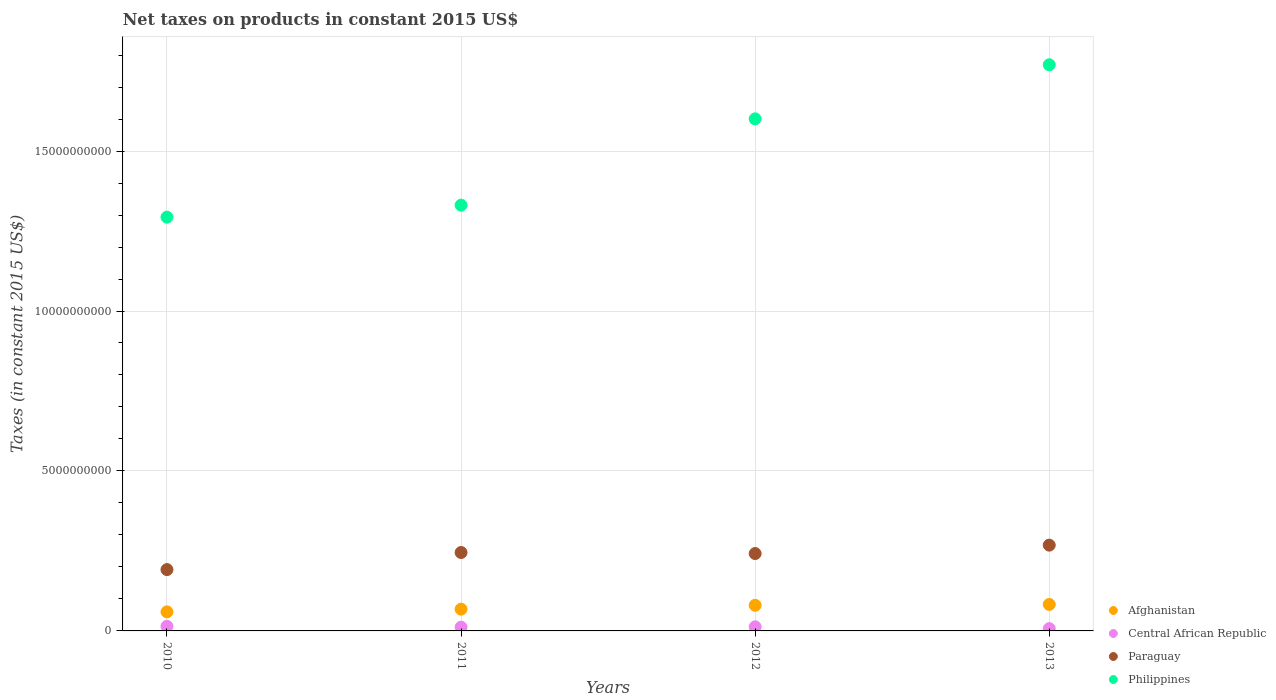How many different coloured dotlines are there?
Keep it short and to the point. 4. Is the number of dotlines equal to the number of legend labels?
Your answer should be compact. Yes. What is the net taxes on products in Paraguay in 2010?
Your answer should be compact. 1.92e+09. Across all years, what is the maximum net taxes on products in Philippines?
Provide a succinct answer. 1.77e+1. Across all years, what is the minimum net taxes on products in Paraguay?
Offer a terse response. 1.92e+09. In which year was the net taxes on products in Afghanistan minimum?
Ensure brevity in your answer.  2010. What is the total net taxes on products in Central African Republic in the graph?
Provide a short and direct response. 4.61e+08. What is the difference between the net taxes on products in Paraguay in 2012 and that in 2013?
Give a very brief answer. -2.63e+08. What is the difference between the net taxes on products in Philippines in 2013 and the net taxes on products in Paraguay in 2010?
Ensure brevity in your answer.  1.58e+1. What is the average net taxes on products in Paraguay per year?
Keep it short and to the point. 2.37e+09. In the year 2012, what is the difference between the net taxes on products in Philippines and net taxes on products in Afghanistan?
Provide a succinct answer. 1.52e+1. What is the ratio of the net taxes on products in Afghanistan in 2010 to that in 2013?
Make the answer very short. 0.72. What is the difference between the highest and the second highest net taxes on products in Paraguay?
Provide a short and direct response. 2.30e+08. What is the difference between the highest and the lowest net taxes on products in Paraguay?
Offer a terse response. 7.64e+08. In how many years, is the net taxes on products in Paraguay greater than the average net taxes on products in Paraguay taken over all years?
Your answer should be very brief. 3. Is it the case that in every year, the sum of the net taxes on products in Philippines and net taxes on products in Afghanistan  is greater than the net taxes on products in Central African Republic?
Provide a short and direct response. Yes. Is the net taxes on products in Central African Republic strictly less than the net taxes on products in Philippines over the years?
Give a very brief answer. Yes. How many dotlines are there?
Provide a short and direct response. 4. What is the difference between two consecutive major ticks on the Y-axis?
Your answer should be compact. 5.00e+09. Does the graph contain any zero values?
Give a very brief answer. No. Does the graph contain grids?
Your response must be concise. Yes. How many legend labels are there?
Your answer should be very brief. 4. How are the legend labels stacked?
Your answer should be very brief. Vertical. What is the title of the graph?
Your answer should be compact. Net taxes on products in constant 2015 US$. What is the label or title of the X-axis?
Your answer should be compact. Years. What is the label or title of the Y-axis?
Your answer should be compact. Taxes (in constant 2015 US$). What is the Taxes (in constant 2015 US$) in Afghanistan in 2010?
Your response must be concise. 5.96e+08. What is the Taxes (in constant 2015 US$) of Central African Republic in 2010?
Keep it short and to the point. 1.43e+08. What is the Taxes (in constant 2015 US$) of Paraguay in 2010?
Keep it short and to the point. 1.92e+09. What is the Taxes (in constant 2015 US$) in Philippines in 2010?
Offer a very short reply. 1.29e+1. What is the Taxes (in constant 2015 US$) of Afghanistan in 2011?
Provide a succinct answer. 6.80e+08. What is the Taxes (in constant 2015 US$) in Central African Republic in 2011?
Provide a short and direct response. 1.17e+08. What is the Taxes (in constant 2015 US$) in Paraguay in 2011?
Provide a succinct answer. 2.45e+09. What is the Taxes (in constant 2015 US$) in Philippines in 2011?
Make the answer very short. 1.33e+1. What is the Taxes (in constant 2015 US$) of Afghanistan in 2012?
Offer a very short reply. 8.01e+08. What is the Taxes (in constant 2015 US$) of Central African Republic in 2012?
Keep it short and to the point. 1.28e+08. What is the Taxes (in constant 2015 US$) in Paraguay in 2012?
Give a very brief answer. 2.42e+09. What is the Taxes (in constant 2015 US$) of Philippines in 2012?
Make the answer very short. 1.60e+1. What is the Taxes (in constant 2015 US$) of Afghanistan in 2013?
Offer a very short reply. 8.28e+08. What is the Taxes (in constant 2015 US$) of Central African Republic in 2013?
Your answer should be very brief. 7.17e+07. What is the Taxes (in constant 2015 US$) in Paraguay in 2013?
Offer a terse response. 2.68e+09. What is the Taxes (in constant 2015 US$) of Philippines in 2013?
Give a very brief answer. 1.77e+1. Across all years, what is the maximum Taxes (in constant 2015 US$) of Afghanistan?
Provide a succinct answer. 8.28e+08. Across all years, what is the maximum Taxes (in constant 2015 US$) of Central African Republic?
Offer a terse response. 1.43e+08. Across all years, what is the maximum Taxes (in constant 2015 US$) in Paraguay?
Your response must be concise. 2.68e+09. Across all years, what is the maximum Taxes (in constant 2015 US$) in Philippines?
Your response must be concise. 1.77e+1. Across all years, what is the minimum Taxes (in constant 2015 US$) in Afghanistan?
Offer a very short reply. 5.96e+08. Across all years, what is the minimum Taxes (in constant 2015 US$) of Central African Republic?
Offer a terse response. 7.17e+07. Across all years, what is the minimum Taxes (in constant 2015 US$) in Paraguay?
Offer a terse response. 1.92e+09. Across all years, what is the minimum Taxes (in constant 2015 US$) in Philippines?
Your response must be concise. 1.29e+1. What is the total Taxes (in constant 2015 US$) in Afghanistan in the graph?
Your answer should be compact. 2.91e+09. What is the total Taxes (in constant 2015 US$) in Central African Republic in the graph?
Make the answer very short. 4.61e+08. What is the total Taxes (in constant 2015 US$) of Paraguay in the graph?
Offer a very short reply. 9.47e+09. What is the total Taxes (in constant 2015 US$) of Philippines in the graph?
Keep it short and to the point. 5.99e+1. What is the difference between the Taxes (in constant 2015 US$) of Afghanistan in 2010 and that in 2011?
Offer a very short reply. -8.40e+07. What is the difference between the Taxes (in constant 2015 US$) of Central African Republic in 2010 and that in 2011?
Give a very brief answer. 2.59e+07. What is the difference between the Taxes (in constant 2015 US$) in Paraguay in 2010 and that in 2011?
Your answer should be compact. -5.34e+08. What is the difference between the Taxes (in constant 2015 US$) of Philippines in 2010 and that in 2011?
Provide a short and direct response. -3.75e+08. What is the difference between the Taxes (in constant 2015 US$) of Afghanistan in 2010 and that in 2012?
Offer a terse response. -2.05e+08. What is the difference between the Taxes (in constant 2015 US$) in Central African Republic in 2010 and that in 2012?
Your response must be concise. 1.51e+07. What is the difference between the Taxes (in constant 2015 US$) of Paraguay in 2010 and that in 2012?
Offer a very short reply. -5.02e+08. What is the difference between the Taxes (in constant 2015 US$) in Philippines in 2010 and that in 2012?
Your answer should be compact. -3.07e+09. What is the difference between the Taxes (in constant 2015 US$) of Afghanistan in 2010 and that in 2013?
Provide a succinct answer. -2.32e+08. What is the difference between the Taxes (in constant 2015 US$) in Central African Republic in 2010 and that in 2013?
Keep it short and to the point. 7.16e+07. What is the difference between the Taxes (in constant 2015 US$) in Paraguay in 2010 and that in 2013?
Provide a succinct answer. -7.64e+08. What is the difference between the Taxes (in constant 2015 US$) of Philippines in 2010 and that in 2013?
Make the answer very short. -4.76e+09. What is the difference between the Taxes (in constant 2015 US$) in Afghanistan in 2011 and that in 2012?
Your answer should be compact. -1.21e+08. What is the difference between the Taxes (in constant 2015 US$) of Central African Republic in 2011 and that in 2012?
Give a very brief answer. -1.09e+07. What is the difference between the Taxes (in constant 2015 US$) of Paraguay in 2011 and that in 2012?
Keep it short and to the point. 3.23e+07. What is the difference between the Taxes (in constant 2015 US$) of Philippines in 2011 and that in 2012?
Your answer should be very brief. -2.70e+09. What is the difference between the Taxes (in constant 2015 US$) in Afghanistan in 2011 and that in 2013?
Ensure brevity in your answer.  -1.48e+08. What is the difference between the Taxes (in constant 2015 US$) of Central African Republic in 2011 and that in 2013?
Your answer should be compact. 4.57e+07. What is the difference between the Taxes (in constant 2015 US$) of Paraguay in 2011 and that in 2013?
Ensure brevity in your answer.  -2.30e+08. What is the difference between the Taxes (in constant 2015 US$) of Philippines in 2011 and that in 2013?
Make the answer very short. -4.39e+09. What is the difference between the Taxes (in constant 2015 US$) in Afghanistan in 2012 and that in 2013?
Make the answer very short. -2.70e+07. What is the difference between the Taxes (in constant 2015 US$) of Central African Republic in 2012 and that in 2013?
Ensure brevity in your answer.  5.66e+07. What is the difference between the Taxes (in constant 2015 US$) in Paraguay in 2012 and that in 2013?
Provide a short and direct response. -2.63e+08. What is the difference between the Taxes (in constant 2015 US$) in Philippines in 2012 and that in 2013?
Keep it short and to the point. -1.69e+09. What is the difference between the Taxes (in constant 2015 US$) in Afghanistan in 2010 and the Taxes (in constant 2015 US$) in Central African Republic in 2011?
Ensure brevity in your answer.  4.79e+08. What is the difference between the Taxes (in constant 2015 US$) of Afghanistan in 2010 and the Taxes (in constant 2015 US$) of Paraguay in 2011?
Offer a terse response. -1.85e+09. What is the difference between the Taxes (in constant 2015 US$) in Afghanistan in 2010 and the Taxes (in constant 2015 US$) in Philippines in 2011?
Your answer should be compact. -1.27e+1. What is the difference between the Taxes (in constant 2015 US$) in Central African Republic in 2010 and the Taxes (in constant 2015 US$) in Paraguay in 2011?
Give a very brief answer. -2.31e+09. What is the difference between the Taxes (in constant 2015 US$) of Central African Republic in 2010 and the Taxes (in constant 2015 US$) of Philippines in 2011?
Give a very brief answer. -1.32e+1. What is the difference between the Taxes (in constant 2015 US$) of Paraguay in 2010 and the Taxes (in constant 2015 US$) of Philippines in 2011?
Keep it short and to the point. -1.14e+1. What is the difference between the Taxes (in constant 2015 US$) of Afghanistan in 2010 and the Taxes (in constant 2015 US$) of Central African Republic in 2012?
Ensure brevity in your answer.  4.68e+08. What is the difference between the Taxes (in constant 2015 US$) in Afghanistan in 2010 and the Taxes (in constant 2015 US$) in Paraguay in 2012?
Your answer should be very brief. -1.82e+09. What is the difference between the Taxes (in constant 2015 US$) in Afghanistan in 2010 and the Taxes (in constant 2015 US$) in Philippines in 2012?
Your answer should be very brief. -1.54e+1. What is the difference between the Taxes (in constant 2015 US$) in Central African Republic in 2010 and the Taxes (in constant 2015 US$) in Paraguay in 2012?
Give a very brief answer. -2.28e+09. What is the difference between the Taxes (in constant 2015 US$) of Central African Republic in 2010 and the Taxes (in constant 2015 US$) of Philippines in 2012?
Offer a very short reply. -1.59e+1. What is the difference between the Taxes (in constant 2015 US$) in Paraguay in 2010 and the Taxes (in constant 2015 US$) in Philippines in 2012?
Ensure brevity in your answer.  -1.41e+1. What is the difference between the Taxes (in constant 2015 US$) of Afghanistan in 2010 and the Taxes (in constant 2015 US$) of Central African Republic in 2013?
Give a very brief answer. 5.24e+08. What is the difference between the Taxes (in constant 2015 US$) of Afghanistan in 2010 and the Taxes (in constant 2015 US$) of Paraguay in 2013?
Provide a short and direct response. -2.09e+09. What is the difference between the Taxes (in constant 2015 US$) of Afghanistan in 2010 and the Taxes (in constant 2015 US$) of Philippines in 2013?
Offer a terse response. -1.71e+1. What is the difference between the Taxes (in constant 2015 US$) in Central African Republic in 2010 and the Taxes (in constant 2015 US$) in Paraguay in 2013?
Give a very brief answer. -2.54e+09. What is the difference between the Taxes (in constant 2015 US$) of Central African Republic in 2010 and the Taxes (in constant 2015 US$) of Philippines in 2013?
Give a very brief answer. -1.76e+1. What is the difference between the Taxes (in constant 2015 US$) in Paraguay in 2010 and the Taxes (in constant 2015 US$) in Philippines in 2013?
Your response must be concise. -1.58e+1. What is the difference between the Taxes (in constant 2015 US$) in Afghanistan in 2011 and the Taxes (in constant 2015 US$) in Central African Republic in 2012?
Provide a short and direct response. 5.52e+08. What is the difference between the Taxes (in constant 2015 US$) in Afghanistan in 2011 and the Taxes (in constant 2015 US$) in Paraguay in 2012?
Keep it short and to the point. -1.74e+09. What is the difference between the Taxes (in constant 2015 US$) of Afghanistan in 2011 and the Taxes (in constant 2015 US$) of Philippines in 2012?
Provide a succinct answer. -1.53e+1. What is the difference between the Taxes (in constant 2015 US$) of Central African Republic in 2011 and the Taxes (in constant 2015 US$) of Paraguay in 2012?
Give a very brief answer. -2.30e+09. What is the difference between the Taxes (in constant 2015 US$) in Central African Republic in 2011 and the Taxes (in constant 2015 US$) in Philippines in 2012?
Offer a very short reply. -1.59e+1. What is the difference between the Taxes (in constant 2015 US$) of Paraguay in 2011 and the Taxes (in constant 2015 US$) of Philippines in 2012?
Offer a very short reply. -1.36e+1. What is the difference between the Taxes (in constant 2015 US$) of Afghanistan in 2011 and the Taxes (in constant 2015 US$) of Central African Republic in 2013?
Ensure brevity in your answer.  6.08e+08. What is the difference between the Taxes (in constant 2015 US$) of Afghanistan in 2011 and the Taxes (in constant 2015 US$) of Paraguay in 2013?
Give a very brief answer. -2.00e+09. What is the difference between the Taxes (in constant 2015 US$) in Afghanistan in 2011 and the Taxes (in constant 2015 US$) in Philippines in 2013?
Offer a terse response. -1.70e+1. What is the difference between the Taxes (in constant 2015 US$) in Central African Republic in 2011 and the Taxes (in constant 2015 US$) in Paraguay in 2013?
Your answer should be very brief. -2.56e+09. What is the difference between the Taxes (in constant 2015 US$) in Central African Republic in 2011 and the Taxes (in constant 2015 US$) in Philippines in 2013?
Offer a very short reply. -1.76e+1. What is the difference between the Taxes (in constant 2015 US$) in Paraguay in 2011 and the Taxes (in constant 2015 US$) in Philippines in 2013?
Give a very brief answer. -1.52e+1. What is the difference between the Taxes (in constant 2015 US$) of Afghanistan in 2012 and the Taxes (in constant 2015 US$) of Central African Republic in 2013?
Your answer should be compact. 7.29e+08. What is the difference between the Taxes (in constant 2015 US$) of Afghanistan in 2012 and the Taxes (in constant 2015 US$) of Paraguay in 2013?
Give a very brief answer. -1.88e+09. What is the difference between the Taxes (in constant 2015 US$) of Afghanistan in 2012 and the Taxes (in constant 2015 US$) of Philippines in 2013?
Provide a succinct answer. -1.69e+1. What is the difference between the Taxes (in constant 2015 US$) in Central African Republic in 2012 and the Taxes (in constant 2015 US$) in Paraguay in 2013?
Give a very brief answer. -2.55e+09. What is the difference between the Taxes (in constant 2015 US$) in Central African Republic in 2012 and the Taxes (in constant 2015 US$) in Philippines in 2013?
Provide a short and direct response. -1.76e+1. What is the difference between the Taxes (in constant 2015 US$) in Paraguay in 2012 and the Taxes (in constant 2015 US$) in Philippines in 2013?
Make the answer very short. -1.53e+1. What is the average Taxes (in constant 2015 US$) of Afghanistan per year?
Your answer should be very brief. 7.26e+08. What is the average Taxes (in constant 2015 US$) of Central African Republic per year?
Make the answer very short. 1.15e+08. What is the average Taxes (in constant 2015 US$) of Paraguay per year?
Make the answer very short. 2.37e+09. What is the average Taxes (in constant 2015 US$) in Philippines per year?
Ensure brevity in your answer.  1.50e+1. In the year 2010, what is the difference between the Taxes (in constant 2015 US$) of Afghanistan and Taxes (in constant 2015 US$) of Central African Republic?
Give a very brief answer. 4.53e+08. In the year 2010, what is the difference between the Taxes (in constant 2015 US$) of Afghanistan and Taxes (in constant 2015 US$) of Paraguay?
Your answer should be very brief. -1.32e+09. In the year 2010, what is the difference between the Taxes (in constant 2015 US$) in Afghanistan and Taxes (in constant 2015 US$) in Philippines?
Keep it short and to the point. -1.23e+1. In the year 2010, what is the difference between the Taxes (in constant 2015 US$) in Central African Republic and Taxes (in constant 2015 US$) in Paraguay?
Give a very brief answer. -1.77e+09. In the year 2010, what is the difference between the Taxes (in constant 2015 US$) in Central African Republic and Taxes (in constant 2015 US$) in Philippines?
Give a very brief answer. -1.28e+1. In the year 2010, what is the difference between the Taxes (in constant 2015 US$) in Paraguay and Taxes (in constant 2015 US$) in Philippines?
Your response must be concise. -1.10e+1. In the year 2011, what is the difference between the Taxes (in constant 2015 US$) of Afghanistan and Taxes (in constant 2015 US$) of Central African Republic?
Make the answer very short. 5.63e+08. In the year 2011, what is the difference between the Taxes (in constant 2015 US$) of Afghanistan and Taxes (in constant 2015 US$) of Paraguay?
Your response must be concise. -1.77e+09. In the year 2011, what is the difference between the Taxes (in constant 2015 US$) of Afghanistan and Taxes (in constant 2015 US$) of Philippines?
Ensure brevity in your answer.  -1.26e+1. In the year 2011, what is the difference between the Taxes (in constant 2015 US$) in Central African Republic and Taxes (in constant 2015 US$) in Paraguay?
Offer a terse response. -2.33e+09. In the year 2011, what is the difference between the Taxes (in constant 2015 US$) in Central African Republic and Taxes (in constant 2015 US$) in Philippines?
Make the answer very short. -1.32e+1. In the year 2011, what is the difference between the Taxes (in constant 2015 US$) in Paraguay and Taxes (in constant 2015 US$) in Philippines?
Your response must be concise. -1.09e+1. In the year 2012, what is the difference between the Taxes (in constant 2015 US$) of Afghanistan and Taxes (in constant 2015 US$) of Central African Republic?
Your response must be concise. 6.73e+08. In the year 2012, what is the difference between the Taxes (in constant 2015 US$) of Afghanistan and Taxes (in constant 2015 US$) of Paraguay?
Provide a short and direct response. -1.62e+09. In the year 2012, what is the difference between the Taxes (in constant 2015 US$) in Afghanistan and Taxes (in constant 2015 US$) in Philippines?
Keep it short and to the point. -1.52e+1. In the year 2012, what is the difference between the Taxes (in constant 2015 US$) in Central African Republic and Taxes (in constant 2015 US$) in Paraguay?
Offer a very short reply. -2.29e+09. In the year 2012, what is the difference between the Taxes (in constant 2015 US$) of Central African Republic and Taxes (in constant 2015 US$) of Philippines?
Your response must be concise. -1.59e+1. In the year 2012, what is the difference between the Taxes (in constant 2015 US$) in Paraguay and Taxes (in constant 2015 US$) in Philippines?
Your answer should be very brief. -1.36e+1. In the year 2013, what is the difference between the Taxes (in constant 2015 US$) of Afghanistan and Taxes (in constant 2015 US$) of Central African Republic?
Offer a very short reply. 7.56e+08. In the year 2013, what is the difference between the Taxes (in constant 2015 US$) of Afghanistan and Taxes (in constant 2015 US$) of Paraguay?
Give a very brief answer. -1.85e+09. In the year 2013, what is the difference between the Taxes (in constant 2015 US$) of Afghanistan and Taxes (in constant 2015 US$) of Philippines?
Make the answer very short. -1.69e+1. In the year 2013, what is the difference between the Taxes (in constant 2015 US$) of Central African Republic and Taxes (in constant 2015 US$) of Paraguay?
Ensure brevity in your answer.  -2.61e+09. In the year 2013, what is the difference between the Taxes (in constant 2015 US$) in Central African Republic and Taxes (in constant 2015 US$) in Philippines?
Give a very brief answer. -1.76e+1. In the year 2013, what is the difference between the Taxes (in constant 2015 US$) of Paraguay and Taxes (in constant 2015 US$) of Philippines?
Provide a succinct answer. -1.50e+1. What is the ratio of the Taxes (in constant 2015 US$) of Afghanistan in 2010 to that in 2011?
Offer a terse response. 0.88. What is the ratio of the Taxes (in constant 2015 US$) in Central African Republic in 2010 to that in 2011?
Provide a short and direct response. 1.22. What is the ratio of the Taxes (in constant 2015 US$) of Paraguay in 2010 to that in 2011?
Offer a terse response. 0.78. What is the ratio of the Taxes (in constant 2015 US$) in Philippines in 2010 to that in 2011?
Offer a terse response. 0.97. What is the ratio of the Taxes (in constant 2015 US$) in Afghanistan in 2010 to that in 2012?
Your response must be concise. 0.74. What is the ratio of the Taxes (in constant 2015 US$) in Central African Republic in 2010 to that in 2012?
Provide a short and direct response. 1.12. What is the ratio of the Taxes (in constant 2015 US$) in Paraguay in 2010 to that in 2012?
Offer a very short reply. 0.79. What is the ratio of the Taxes (in constant 2015 US$) of Philippines in 2010 to that in 2012?
Your response must be concise. 0.81. What is the ratio of the Taxes (in constant 2015 US$) in Afghanistan in 2010 to that in 2013?
Your answer should be very brief. 0.72. What is the ratio of the Taxes (in constant 2015 US$) of Central African Republic in 2010 to that in 2013?
Make the answer very short. 2. What is the ratio of the Taxes (in constant 2015 US$) of Paraguay in 2010 to that in 2013?
Ensure brevity in your answer.  0.71. What is the ratio of the Taxes (in constant 2015 US$) in Philippines in 2010 to that in 2013?
Provide a short and direct response. 0.73. What is the ratio of the Taxes (in constant 2015 US$) of Afghanistan in 2011 to that in 2012?
Offer a terse response. 0.85. What is the ratio of the Taxes (in constant 2015 US$) in Central African Republic in 2011 to that in 2012?
Provide a succinct answer. 0.92. What is the ratio of the Taxes (in constant 2015 US$) in Paraguay in 2011 to that in 2012?
Ensure brevity in your answer.  1.01. What is the ratio of the Taxes (in constant 2015 US$) in Philippines in 2011 to that in 2012?
Keep it short and to the point. 0.83. What is the ratio of the Taxes (in constant 2015 US$) in Afghanistan in 2011 to that in 2013?
Make the answer very short. 0.82. What is the ratio of the Taxes (in constant 2015 US$) of Central African Republic in 2011 to that in 2013?
Your response must be concise. 1.64. What is the ratio of the Taxes (in constant 2015 US$) in Paraguay in 2011 to that in 2013?
Offer a terse response. 0.91. What is the ratio of the Taxes (in constant 2015 US$) in Philippines in 2011 to that in 2013?
Your answer should be very brief. 0.75. What is the ratio of the Taxes (in constant 2015 US$) of Afghanistan in 2012 to that in 2013?
Your answer should be very brief. 0.97. What is the ratio of the Taxes (in constant 2015 US$) in Central African Republic in 2012 to that in 2013?
Your answer should be very brief. 1.79. What is the ratio of the Taxes (in constant 2015 US$) in Paraguay in 2012 to that in 2013?
Provide a short and direct response. 0.9. What is the ratio of the Taxes (in constant 2015 US$) in Philippines in 2012 to that in 2013?
Your response must be concise. 0.9. What is the difference between the highest and the second highest Taxes (in constant 2015 US$) in Afghanistan?
Provide a short and direct response. 2.70e+07. What is the difference between the highest and the second highest Taxes (in constant 2015 US$) of Central African Republic?
Your response must be concise. 1.51e+07. What is the difference between the highest and the second highest Taxes (in constant 2015 US$) in Paraguay?
Provide a succinct answer. 2.30e+08. What is the difference between the highest and the second highest Taxes (in constant 2015 US$) of Philippines?
Your answer should be compact. 1.69e+09. What is the difference between the highest and the lowest Taxes (in constant 2015 US$) in Afghanistan?
Offer a very short reply. 2.32e+08. What is the difference between the highest and the lowest Taxes (in constant 2015 US$) in Central African Republic?
Give a very brief answer. 7.16e+07. What is the difference between the highest and the lowest Taxes (in constant 2015 US$) of Paraguay?
Make the answer very short. 7.64e+08. What is the difference between the highest and the lowest Taxes (in constant 2015 US$) of Philippines?
Provide a succinct answer. 4.76e+09. 